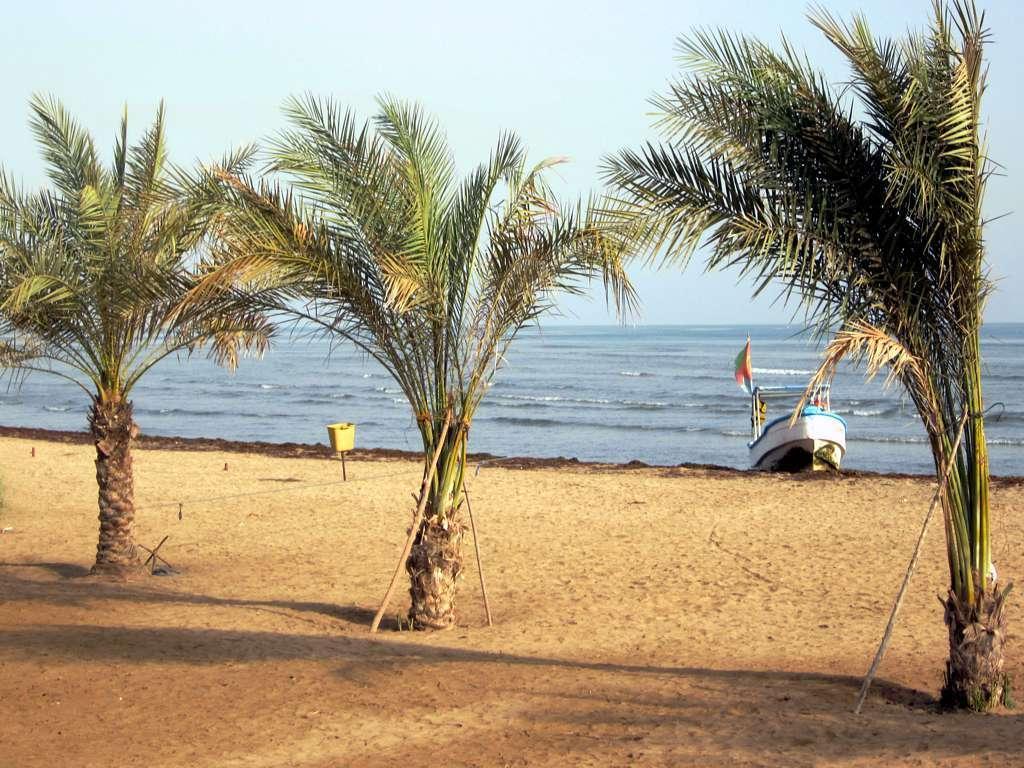Describe this image in one or two sentences. In this image we can see trees, sand, boat, water and sky. 